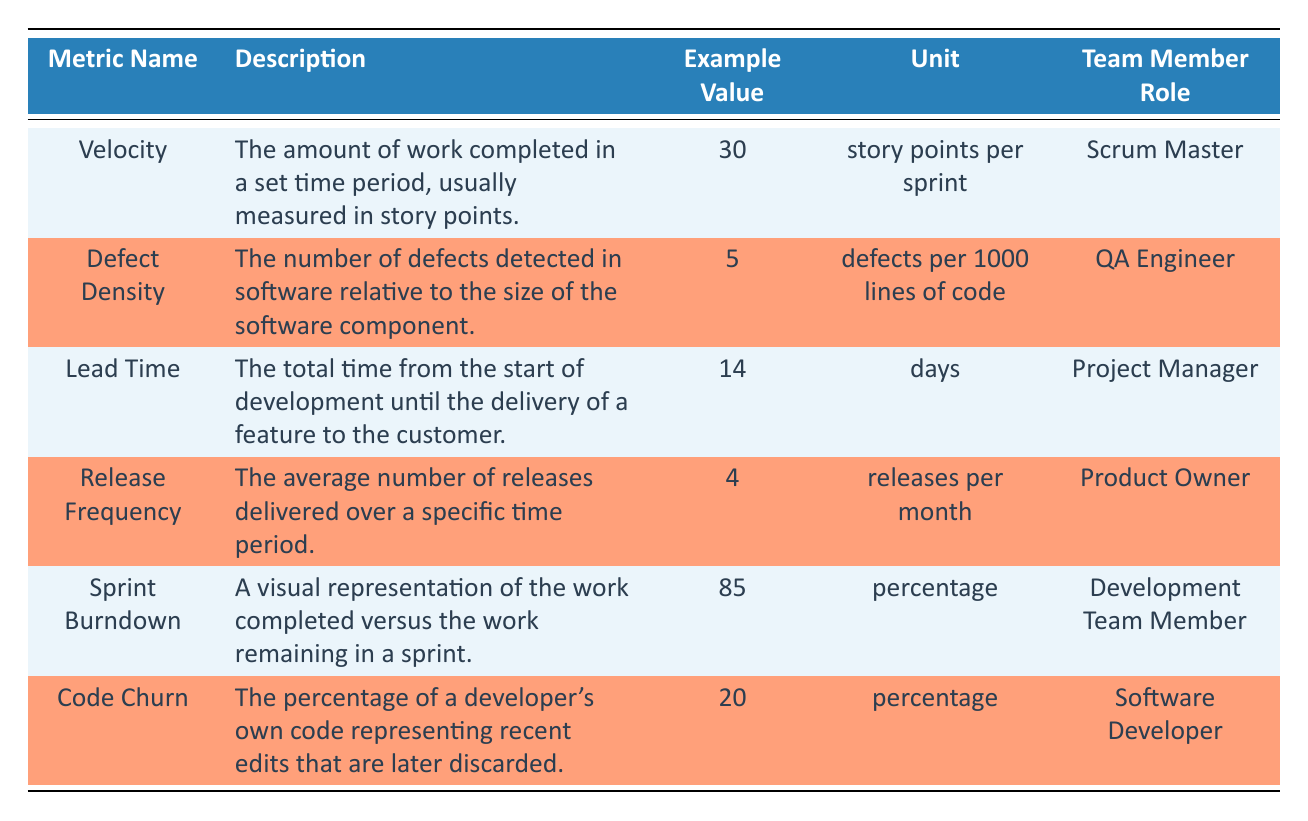What is the example value of Velocity? The example value for Velocity is given directly in the table under the "Example Value" column for the corresponding metric name "Velocity".
Answer: 30 What unit is used to measure Defect Density? The unit for Defect Density is specified in the table under the "Unit" column for the metric "Defect Density".
Answer: defects per 1000 lines of code Which team member role is responsible for measuring Lead Time? The team member role associated with Lead Time is listed in the "Team Member Role" column for the Lead Time metric. This role is specified as "Project Manager".
Answer: Project Manager Is the example value for Release Frequency greater than 3? The example value for Release Frequency is noted in the table, and it is 4. Since 4 is indeed greater than 3, the answer is yes.
Answer: Yes What is the average example value of Metric Names that have a percentage unit? The metrics with a percentage unit are Sprint Burndown (85) and Code Churn (20). First, we sum these values: 85 + 20 = 105, then we divide by the number of metrics, which is 2 giving us 105 / 2 = 52.5 as the average.
Answer: 52.5 Which metric has the lowest example value? By examining the example values in the table, we see that the lowest value is associated with Defect Density (5). We compare all example values: 30, 5, 14, 4, 85, and 20, and identify that 5 is the smallest.
Answer: Defect Density Is there a metric that has both a unit of "percentage" and is linked to a Scrum role? Upon reviewing the table, we find that the metrics Code Churn and Sprint Burndown have the unit "percentage", but neither is exclusively tied to a Scrum role. Code Churn is linked to a "Software Developer" and Sprint Burndown to a "Development Team Member", thus the answer is no.
Answer: No What total work has to be done in Sprint Burndown if currently 85 percent of work is completed? If 85 percent work is completed, it implies that 15 percent of work remains to be done. This does not require additional data beyond the single metric reference.
Answer: 15 percent Which metric relates to the role of Software Developer? The role of Software Developer is linked to the metric, Code Churn, which is specified in the table. This is evident by reviewing the entries under the "Team Member Role" column corresponding to the metric name.
Answer: Code Churn 